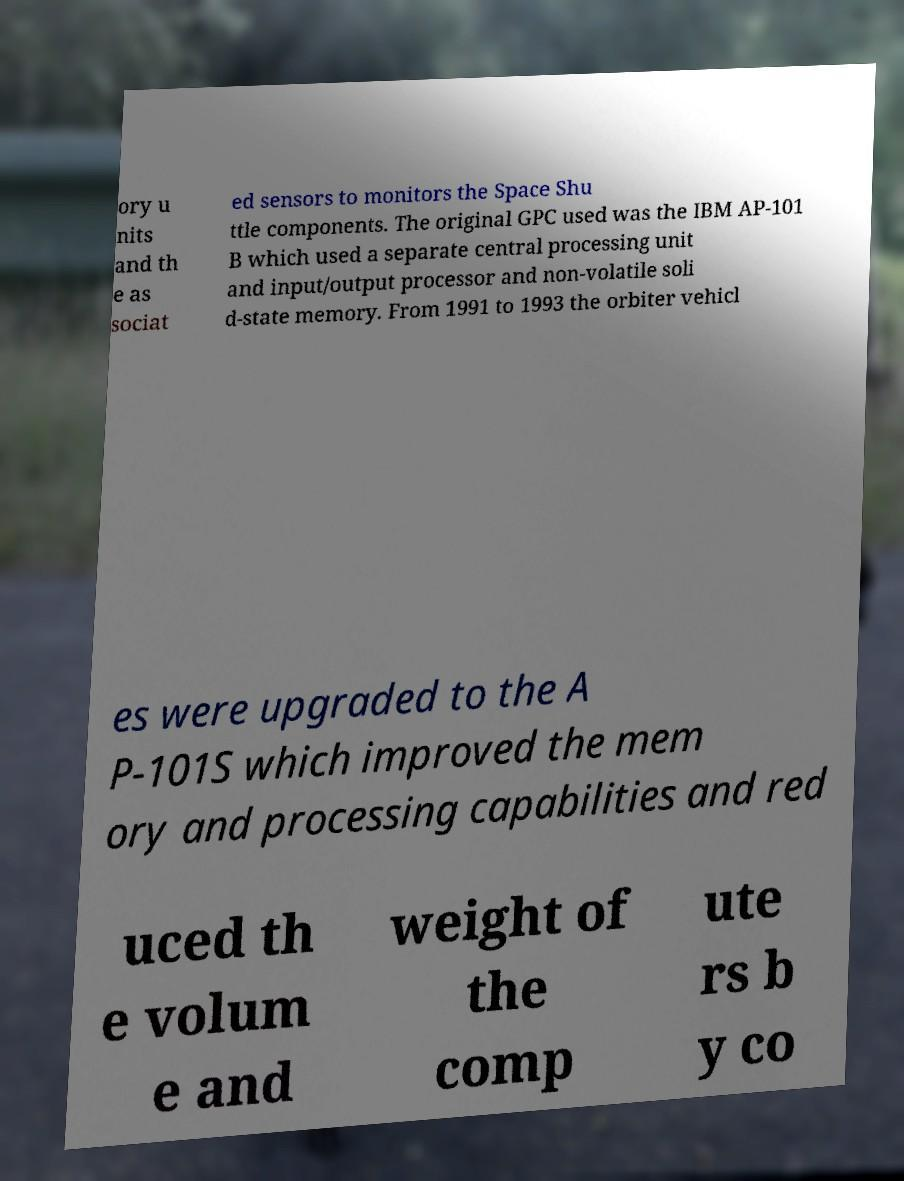Could you assist in decoding the text presented in this image and type it out clearly? ory u nits and th e as sociat ed sensors to monitors the Space Shu ttle components. The original GPC used was the IBM AP-101 B which used a separate central processing unit and input/output processor and non-volatile soli d-state memory. From 1991 to 1993 the orbiter vehicl es were upgraded to the A P-101S which improved the mem ory and processing capabilities and red uced th e volum e and weight of the comp ute rs b y co 